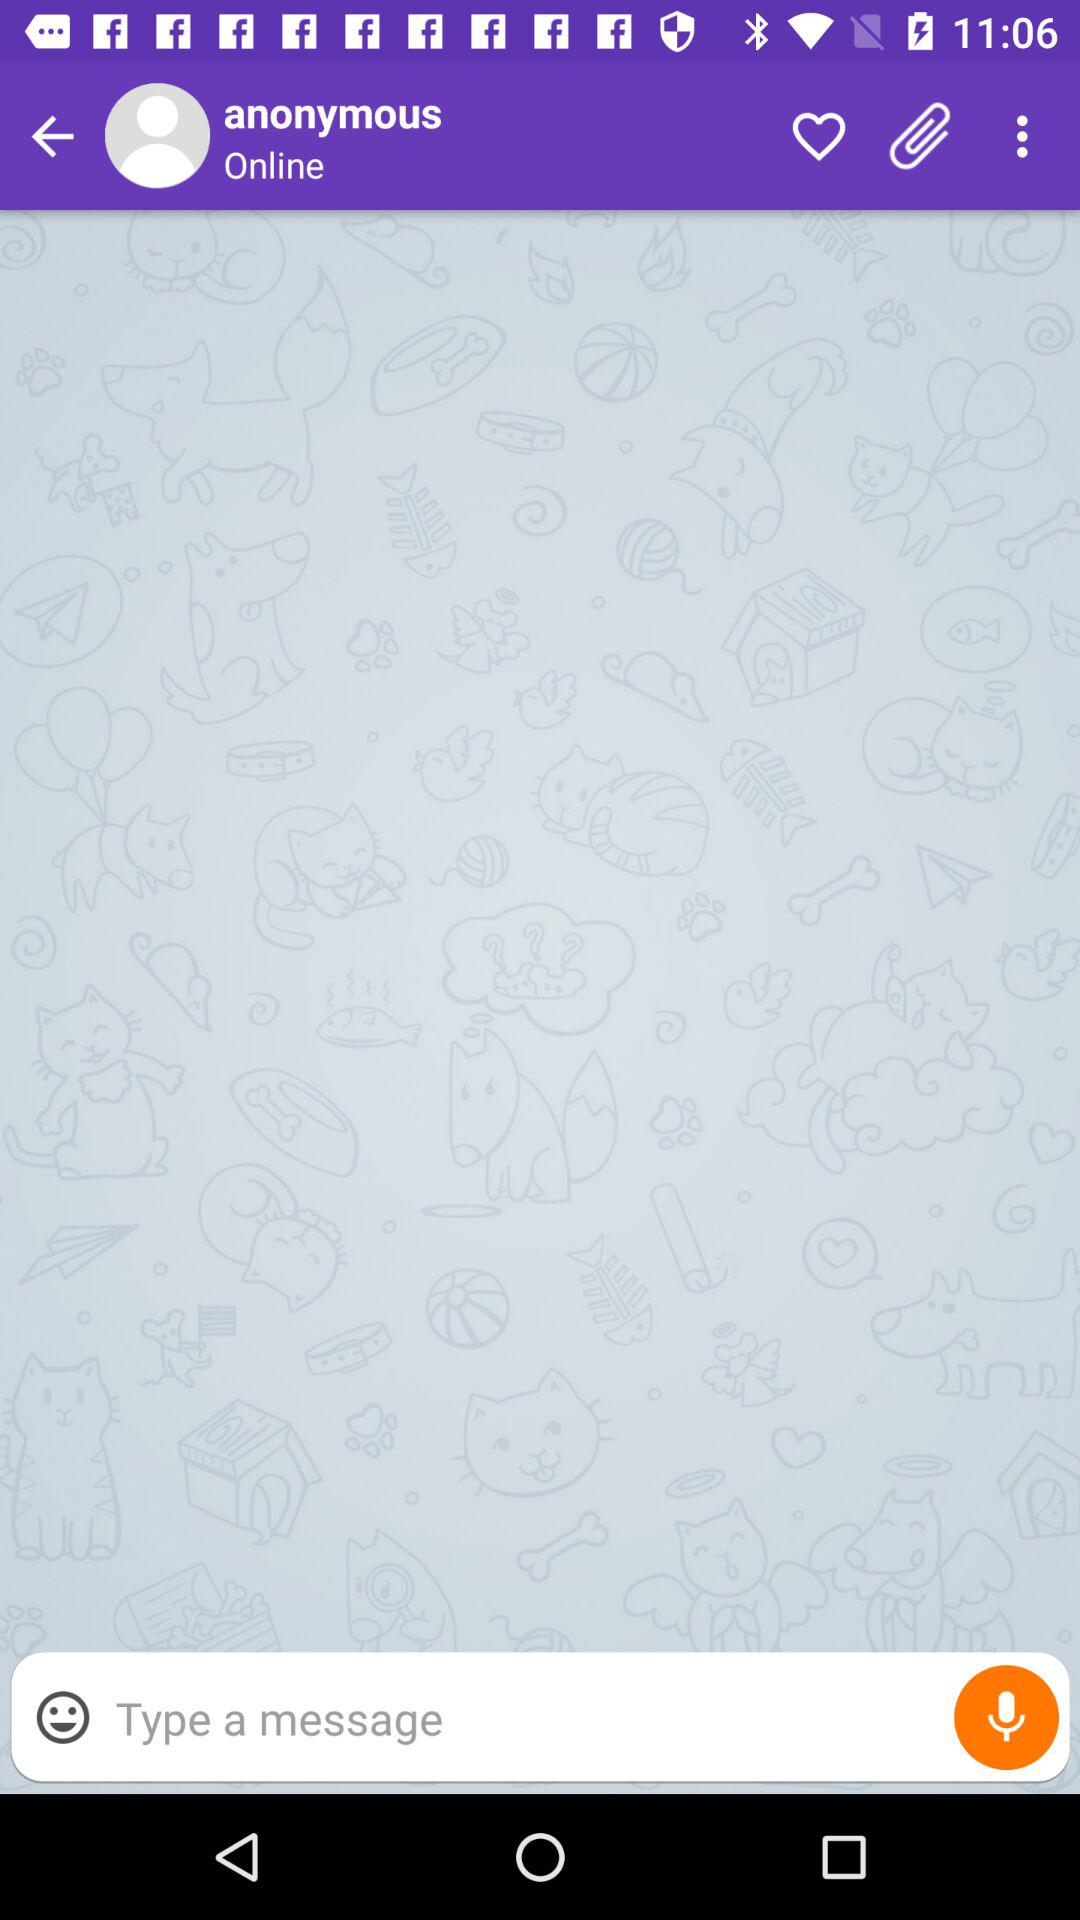When was the message sent?
When the provided information is insufficient, respond with <no answer>. <no answer> 